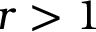<formula> <loc_0><loc_0><loc_500><loc_500>r > 1</formula> 